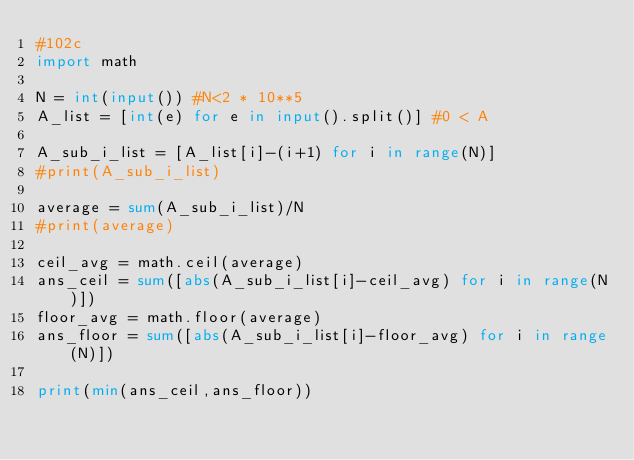Convert code to text. <code><loc_0><loc_0><loc_500><loc_500><_Python_>#102c
import math

N = int(input()) #N<2 * 10**5
A_list = [int(e) for e in input().split()] #0 < A

A_sub_i_list = [A_list[i]-(i+1) for i in range(N)]
#print(A_sub_i_list)

average = sum(A_sub_i_list)/N
#print(average)

ceil_avg = math.ceil(average)
ans_ceil = sum([abs(A_sub_i_list[i]-ceil_avg) for i in range(N)])
floor_avg = math.floor(average)
ans_floor = sum([abs(A_sub_i_list[i]-floor_avg) for i in range(N)])

print(min(ans_ceil,ans_floor))</code> 